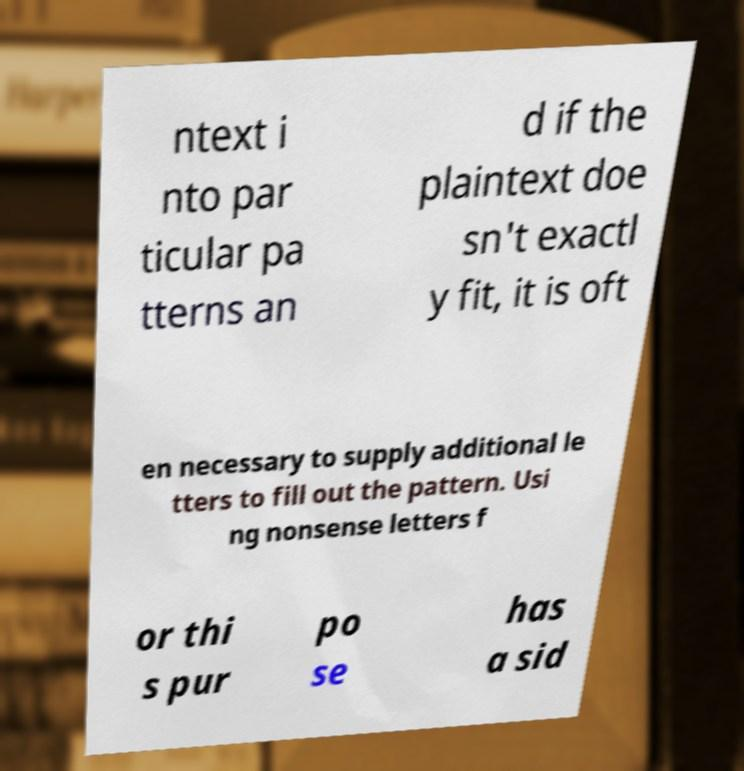Could you extract and type out the text from this image? ntext i nto par ticular pa tterns an d if the plaintext doe sn't exactl y fit, it is oft en necessary to supply additional le tters to fill out the pattern. Usi ng nonsense letters f or thi s pur po se has a sid 